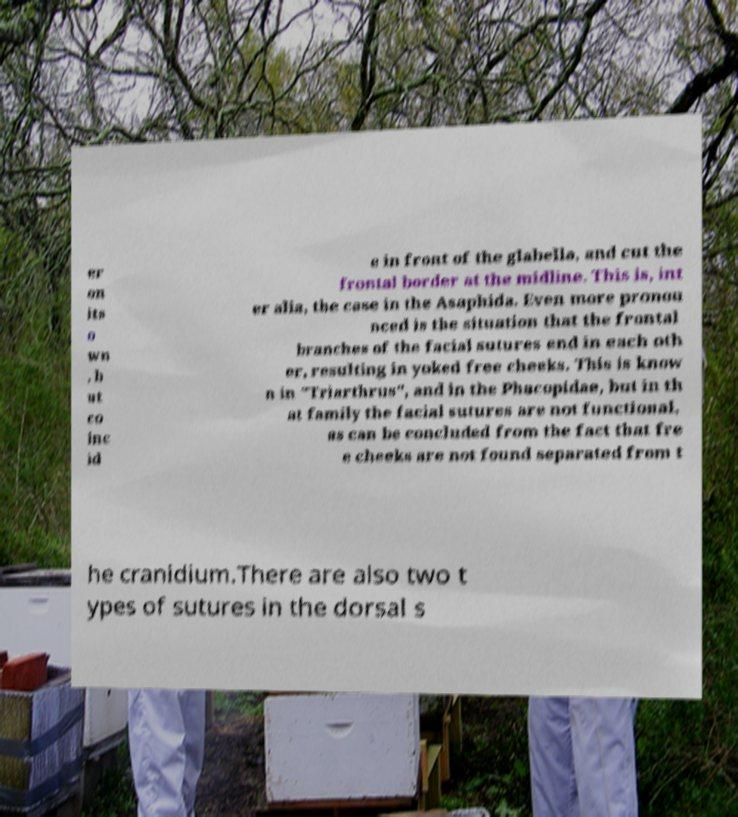For documentation purposes, I need the text within this image transcribed. Could you provide that? er on its o wn , b ut co inc id e in front of the glabella, and cut the frontal border at the midline. This is, int er alia, the case in the Asaphida. Even more pronou nced is the situation that the frontal branches of the facial sutures end in each oth er, resulting in yoked free cheeks. This is know n in "Triarthrus", and in the Phacopidae, but in th at family the facial sutures are not functional, as can be concluded from the fact that fre e cheeks are not found separated from t he cranidium.There are also two t ypes of sutures in the dorsal s 